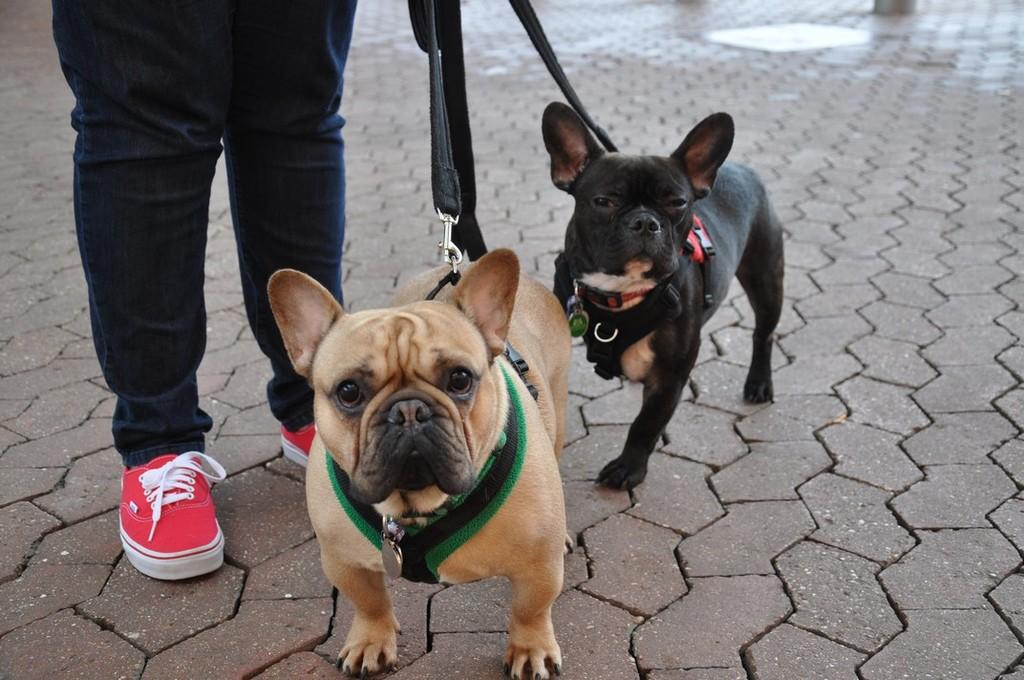Who or what is present in the image? There is a person in the image. What type of clothing is the person wearing? The person is wearing jeans. What color are the shoes the person is wearing? The person is wearing red shoes. What is the person holding in the image? The person is holding two dogs. What type of beef is being served to the girl in the image? There is no girl or beef present in the image; it features a person holding two dogs. How many birds are in the flock that is visible in the image? There is no flock of birds present in the image. 